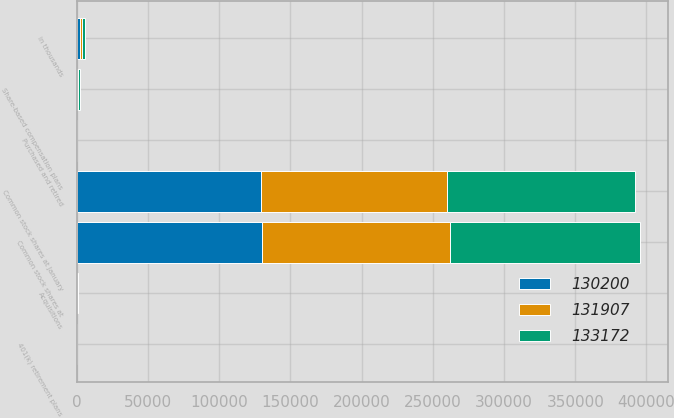<chart> <loc_0><loc_0><loc_500><loc_500><stacked_bar_chart><ecel><fcel>in thousands<fcel>Common stock shares at January<fcel>Acquisitions<fcel>401(k) retirement plans<fcel>Share-based compensation plans<fcel>Purchased and retired<fcel>Common stock shares at<nl><fcel>133172<fcel>2015<fcel>131907<fcel>0<fcel>0<fcel>1493<fcel>228<fcel>133172<nl><fcel>131907<fcel>2014<fcel>130200<fcel>715<fcel>485<fcel>507<fcel>0<fcel>131907<nl><fcel>130200<fcel>2013<fcel>129721<fcel>0<fcel>71<fcel>408<fcel>0<fcel>130200<nl></chart> 